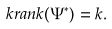Convert formula to latex. <formula><loc_0><loc_0><loc_500><loc_500>\ k r a n k ( \Psi ^ { * } ) = k .</formula> 